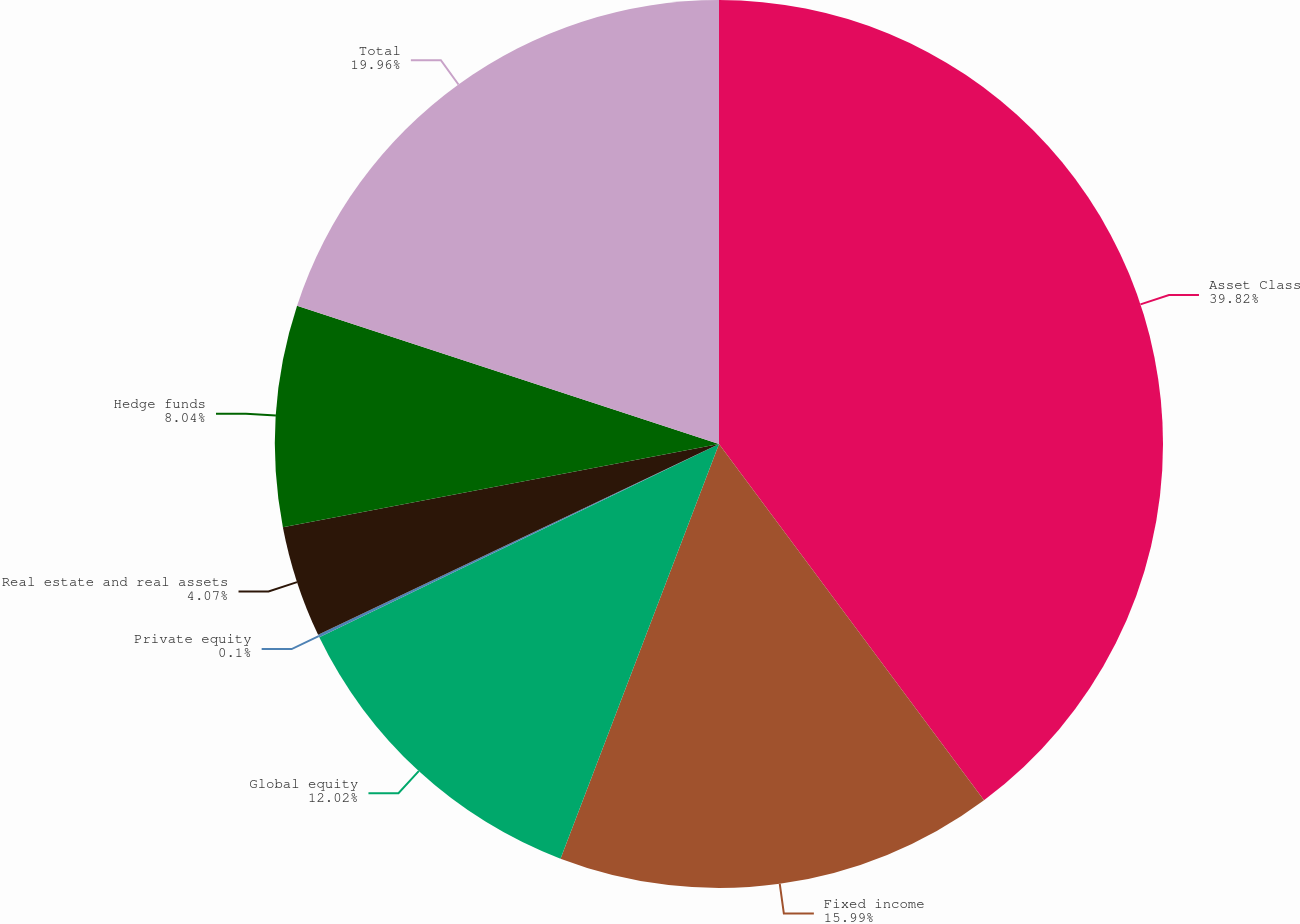Convert chart to OTSL. <chart><loc_0><loc_0><loc_500><loc_500><pie_chart><fcel>Asset Class<fcel>Fixed income<fcel>Global equity<fcel>Private equity<fcel>Real estate and real assets<fcel>Hedge funds<fcel>Total<nl><fcel>39.82%<fcel>15.99%<fcel>12.02%<fcel>0.1%<fcel>4.07%<fcel>8.04%<fcel>19.96%<nl></chart> 